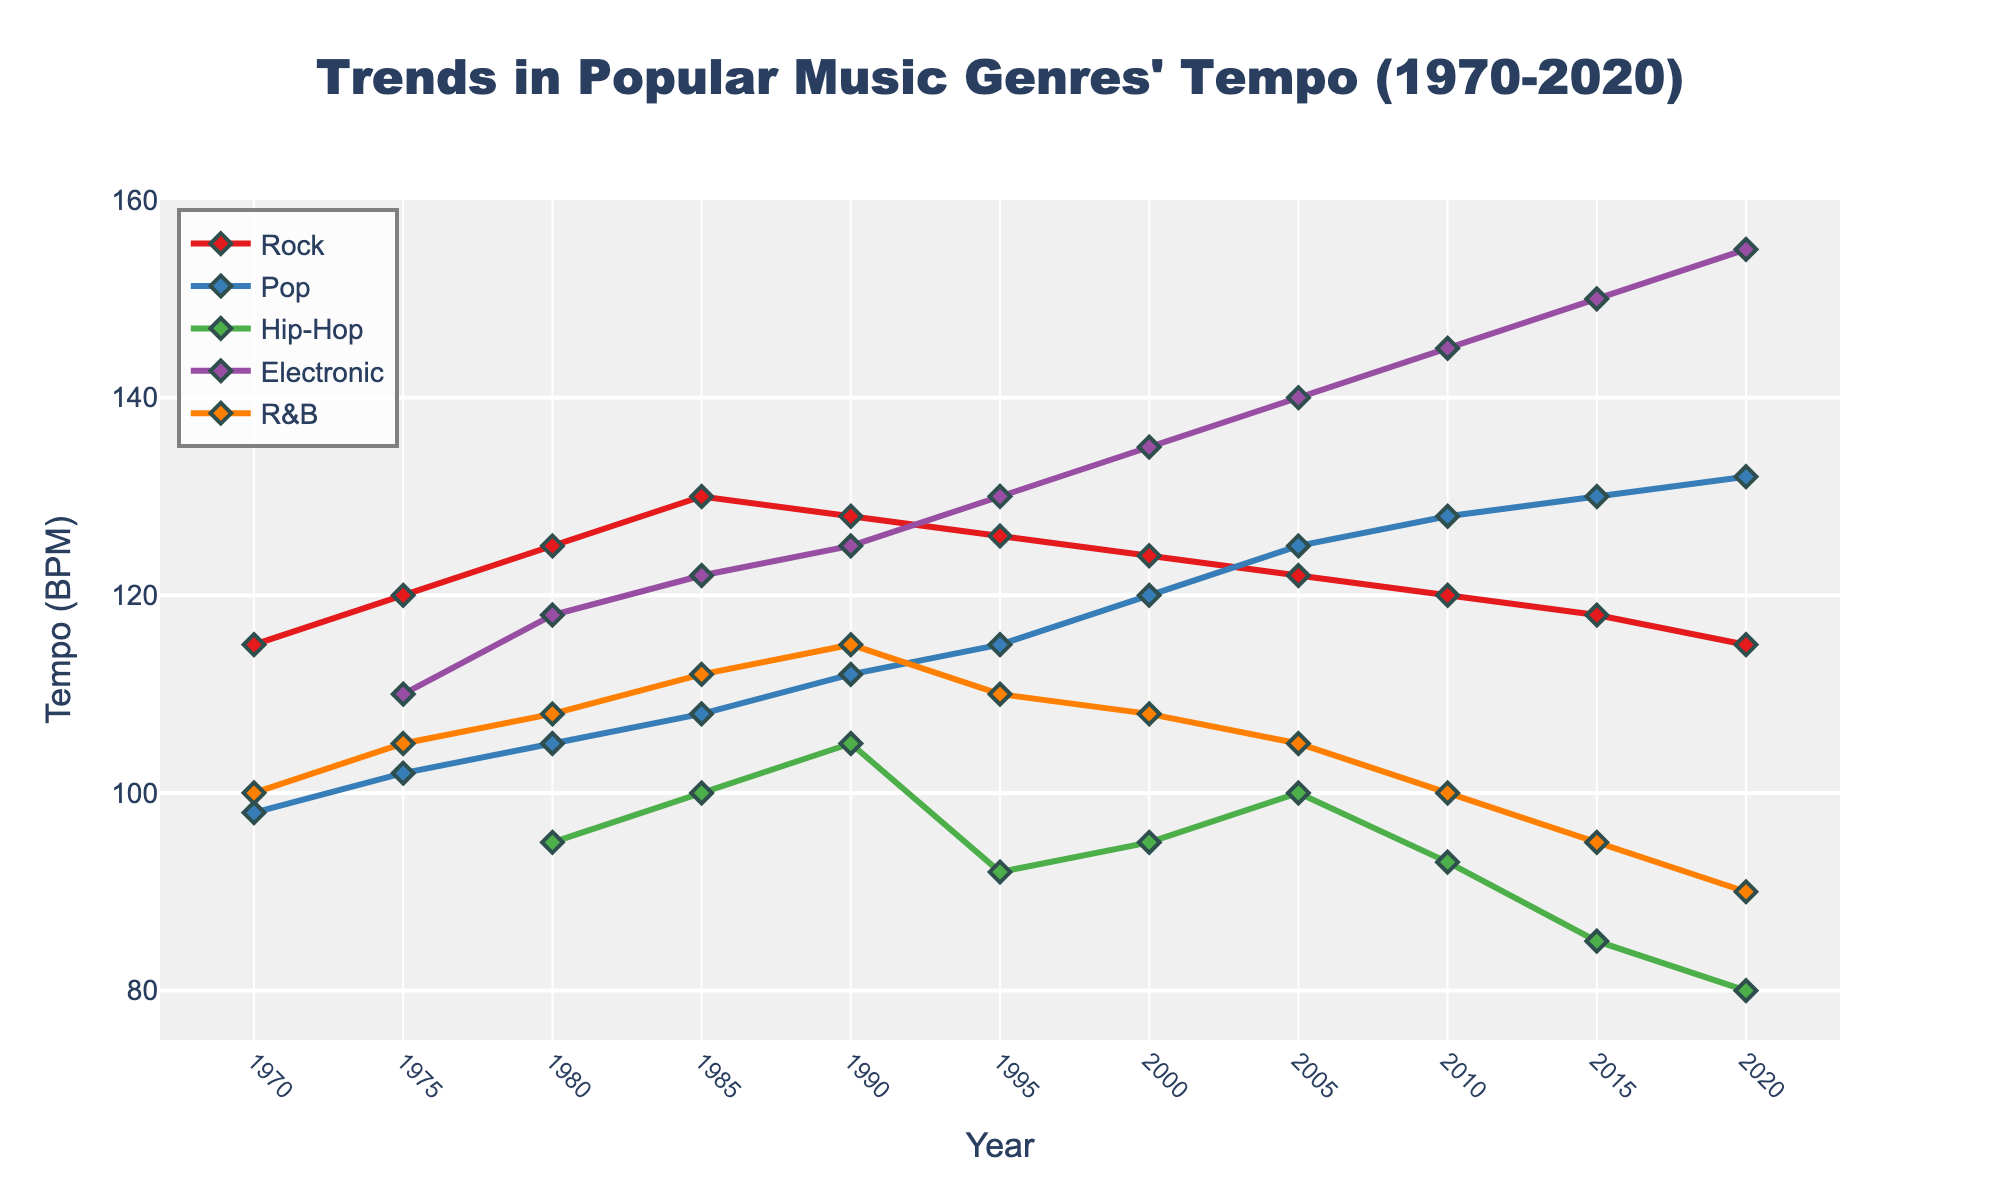What year did Pop music have the highest tempo? In the figure, we can see that the tempo of Pop music increased over the years. The highest tempo for Pop music is 132 BPM in the year 2020.
Answer: 2020 How did the tempo of Rock music change from 1970 to 2020? To determine the change in the tempo of Rock music from 1970 to 2020, we subtract the tempo in 1970 (115 BPM) from the tempo in 2020 (115 BPM). The difference is 0 BPM, indicating no change.
Answer: 0 BPM Which genre showed the largest increase in tempo from 1970 to 2020? By comparing the tempo of each genre in 1970 and 2020, we find the increases: Electronic (155-110 = 45 BPM), Pop (132-98 = 34 BPM), Rock (115-115 = 0 BPM), R&B (90-100 = -10 BPM), Hip-Hop (N/A-80 = N/A). Hence, Electronic showed the largest increase at 45 BPM.
Answer: Electronic In what year did Hip-Hop music have a notable change in its tempo trend? Observing the trend for Hip-Hop music, it first appears in 1980 with a tempo of 95 BPM and shows toggling tempo values but notably drops to 80 BPM in 2020, indicating a continuous trend change.
Answer: 2020 Which genres had a slower tempo in 2020 compared to 1970? We compare the tempo values of genres between 1970 and 2020: Rock (115 to 115), Pop (98 to 132), Hip-Hop (N/A to 80), Electronic (N/A to 155), R&B (100 to 90). Thus, only R&B had a slower tempo, decreasing from 100 BPM to 90 BPM.
Answer: R&B What is the average tempo of Rock music across all the years shown? Adding up the tempo values for Rock music from 1970 to 2020 (115+120+125+130+128+126+124+122+120+118+115=1373) and dividing by the number of years (11), we get an average of approximately 124.82 BPM.
Answer: 124.82 BPM Compare the tempo trends of Pop and R&B from 1980 to 2020. Pop’s tempo data: 105 in 1980 rising to 132 in 2020. R&B’s tempo data: 108 in 1980 declining to 90 in 2020. While Pop shows a generally increasing trend, R&B exhibits a decreasing trend over the same period.
Answer: Pop increasing, R&B decreasing Did any genre reach a peak tempo multiple times? By examining the peaks of each genre: Rock, Pop, Hip-Hop, Electronic, R&B, we notice that no genre reached its peak tempo more than once across the years presented.
Answer: No 